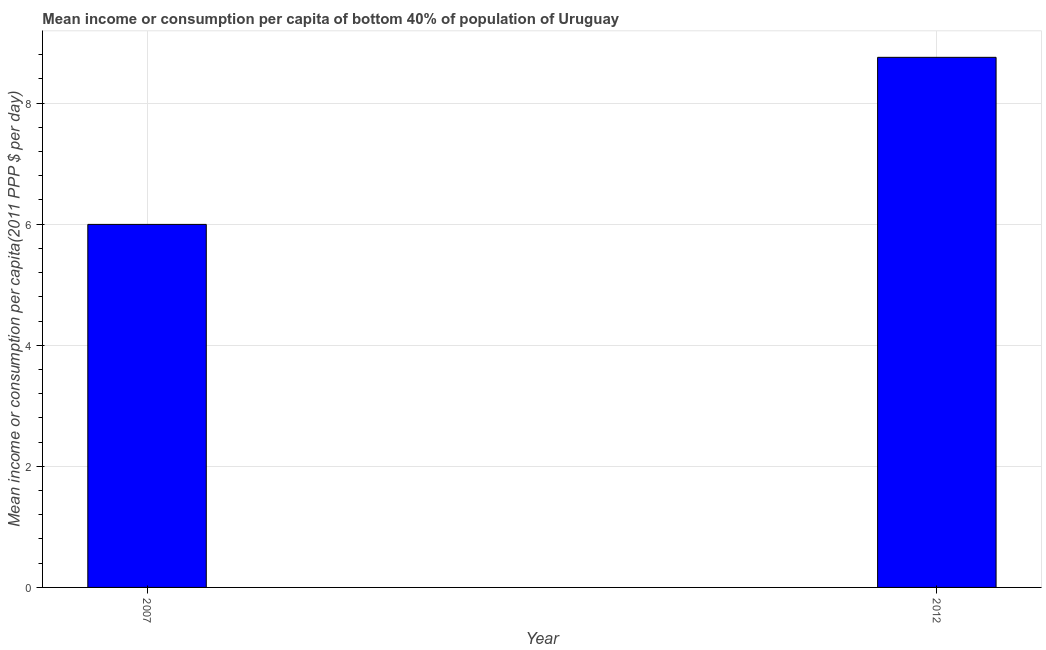Does the graph contain any zero values?
Ensure brevity in your answer.  No. Does the graph contain grids?
Give a very brief answer. Yes. What is the title of the graph?
Ensure brevity in your answer.  Mean income or consumption per capita of bottom 40% of population of Uruguay. What is the label or title of the Y-axis?
Your response must be concise. Mean income or consumption per capita(2011 PPP $ per day). What is the mean income or consumption in 2007?
Offer a terse response. 6. Across all years, what is the maximum mean income or consumption?
Make the answer very short. 8.75. Across all years, what is the minimum mean income or consumption?
Offer a terse response. 6. In which year was the mean income or consumption maximum?
Offer a very short reply. 2012. What is the sum of the mean income or consumption?
Give a very brief answer. 14.75. What is the difference between the mean income or consumption in 2007 and 2012?
Make the answer very short. -2.76. What is the average mean income or consumption per year?
Offer a very short reply. 7.38. What is the median mean income or consumption?
Give a very brief answer. 7.38. Do a majority of the years between 2007 and 2012 (inclusive) have mean income or consumption greater than 2 $?
Provide a succinct answer. Yes. What is the ratio of the mean income or consumption in 2007 to that in 2012?
Your answer should be compact. 0.69. In how many years, is the mean income or consumption greater than the average mean income or consumption taken over all years?
Provide a short and direct response. 1. How many bars are there?
Offer a very short reply. 2. Are all the bars in the graph horizontal?
Your response must be concise. No. How many years are there in the graph?
Give a very brief answer. 2. What is the difference between two consecutive major ticks on the Y-axis?
Your answer should be very brief. 2. What is the Mean income or consumption per capita(2011 PPP $ per day) of 2007?
Ensure brevity in your answer.  6. What is the Mean income or consumption per capita(2011 PPP $ per day) in 2012?
Offer a very short reply. 8.75. What is the difference between the Mean income or consumption per capita(2011 PPP $ per day) in 2007 and 2012?
Give a very brief answer. -2.76. What is the ratio of the Mean income or consumption per capita(2011 PPP $ per day) in 2007 to that in 2012?
Make the answer very short. 0.69. 